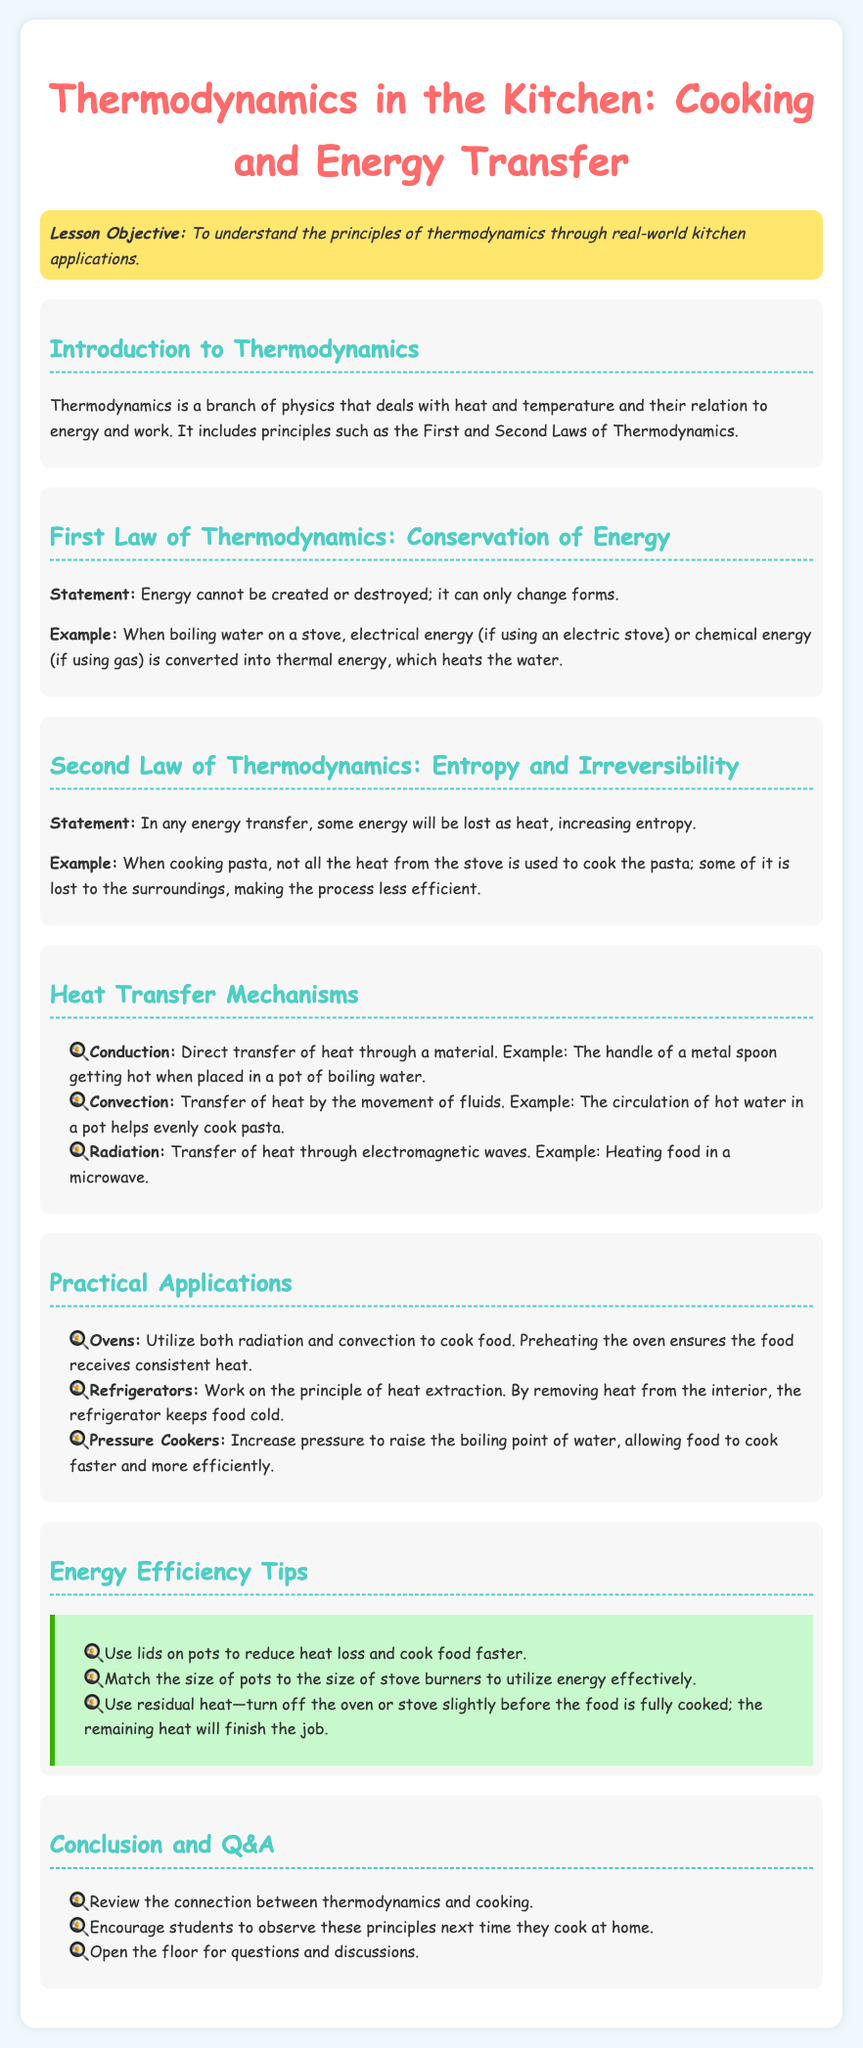What is the lesson objective? The lesson objective is stated in the document to help understand the principles of thermodynamics through real-world kitchen applications.
Answer: To understand the principles of thermodynamics through real-world kitchen applications What is the First Law of Thermodynamics? The First Law is mentioned in the document with its statement, highlighting energy conservation as it relates to cooking.
Answer: Energy cannot be created or destroyed; it can only change forms Give an example of heat transfer through conduction. The document provides a specific example of conduction related to kitchen activities.
Answer: The handle of a metal spoon getting hot when placed in a pot of boiling water What cooking appliance utilizes radiation and convection? This question refers to the practical applications section of the document that describes cooking methods.
Answer: Ovens What is a tip for improving energy efficiency when cooking? The document lists several energy efficiency tips under its dedicated section.
Answer: Use lids on pots to reduce heat loss and cook food faster How does a refrigerator work according to the document? The document explains the working principle of refrigerators in the context of thermodynamics.
Answer: By removing heat from the interior What does the Second Law of Thermodynamics state? The document includes the statement of the Second Law along with a relevant example for better understanding.
Answer: In any energy transfer, some energy will be lost as heat, increasing entropy What type of document is this? This question pertains to the nature and intent of the content within the document structure.
Answer: Lesson plan 